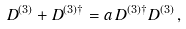Convert formula to latex. <formula><loc_0><loc_0><loc_500><loc_500>D ^ { ( 3 ) } + D ^ { ( 3 ) \dag } = a \, D ^ { ( 3 ) \dag } D ^ { ( 3 ) } \, ,</formula> 